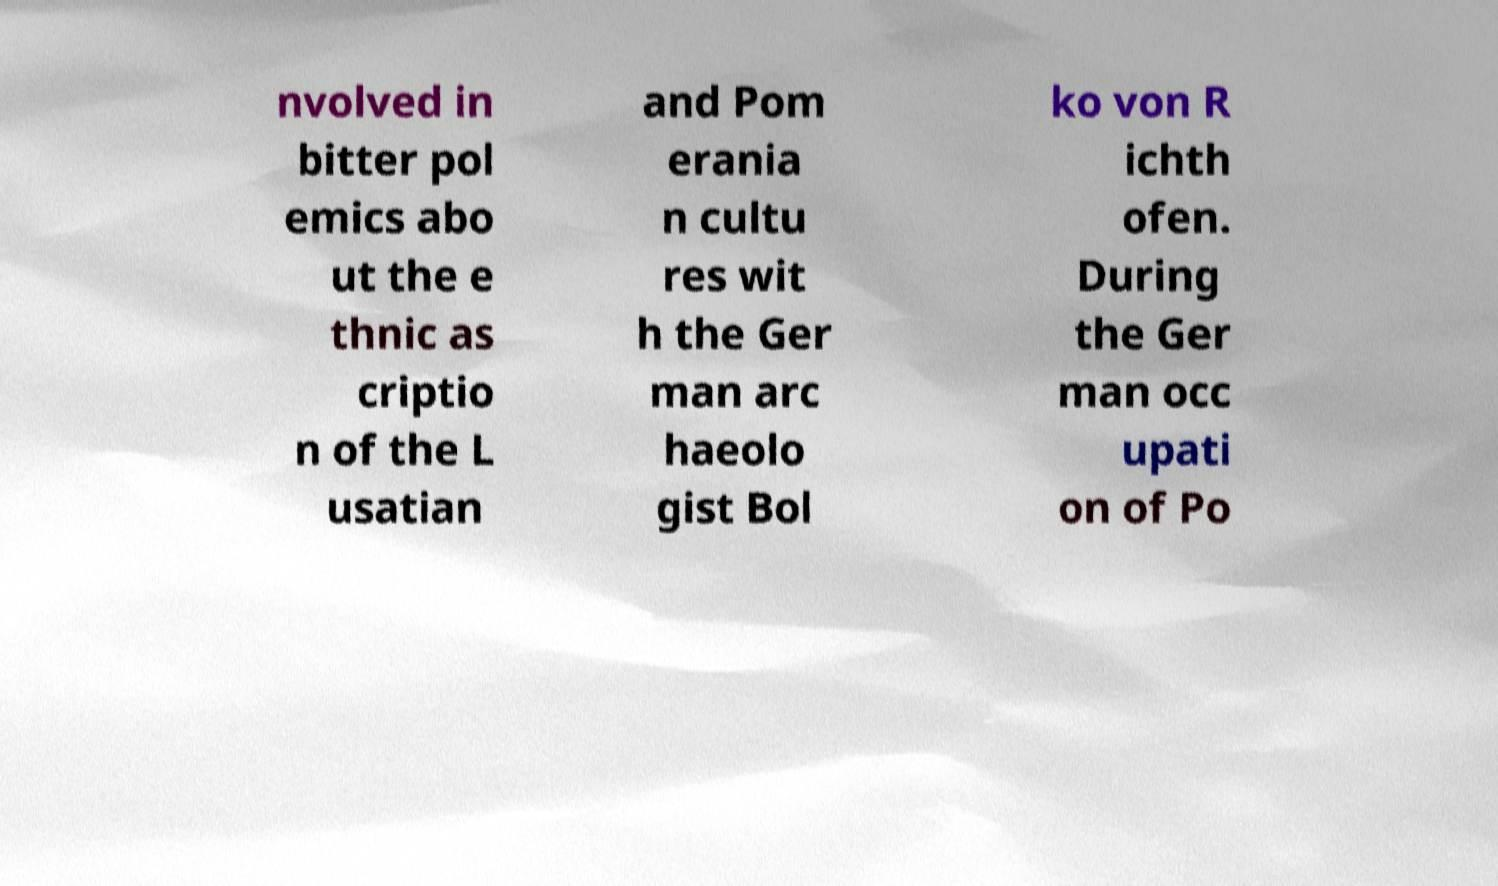What messages or text are displayed in this image? I need them in a readable, typed format. nvolved in bitter pol emics abo ut the e thnic as criptio n of the L usatian and Pom erania n cultu res wit h the Ger man arc haeolo gist Bol ko von R ichth ofen. During the Ger man occ upati on of Po 